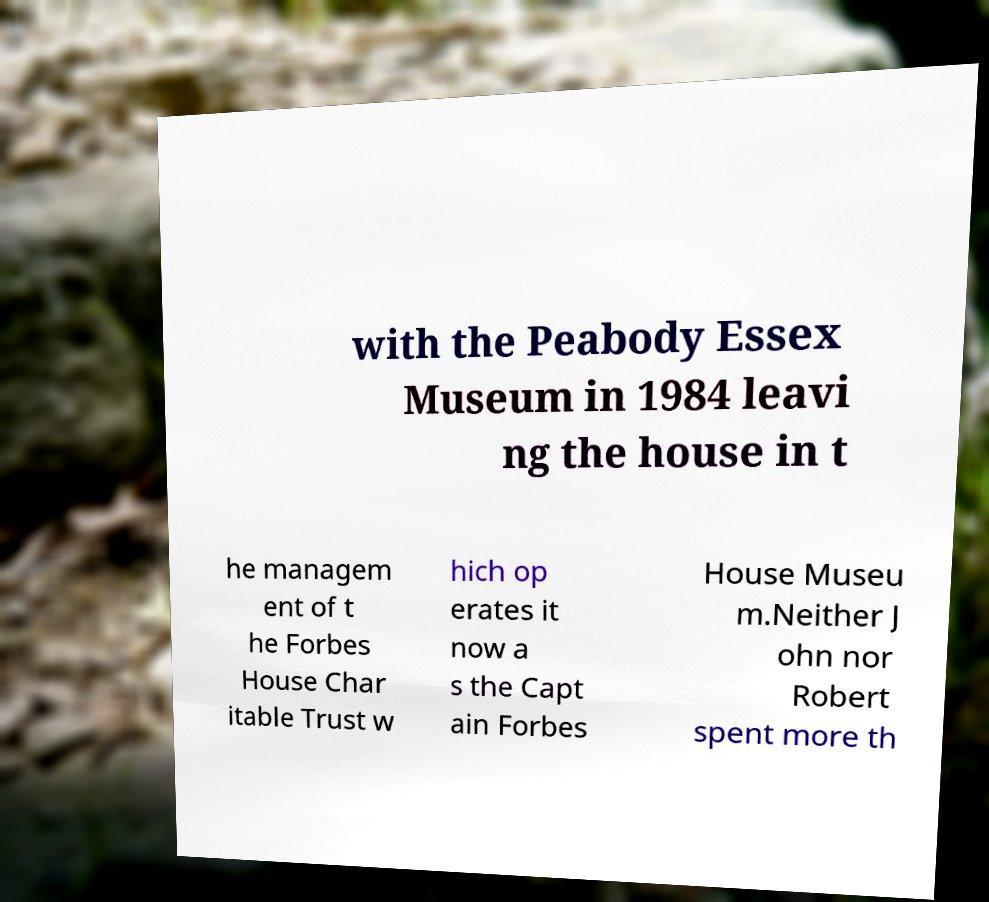Could you extract and type out the text from this image? with the Peabody Essex Museum in 1984 leavi ng the house in t he managem ent of t he Forbes House Char itable Trust w hich op erates it now a s the Capt ain Forbes House Museu m.Neither J ohn nor Robert spent more th 